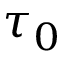Convert formula to latex. <formula><loc_0><loc_0><loc_500><loc_500>\tau _ { 0 }</formula> 